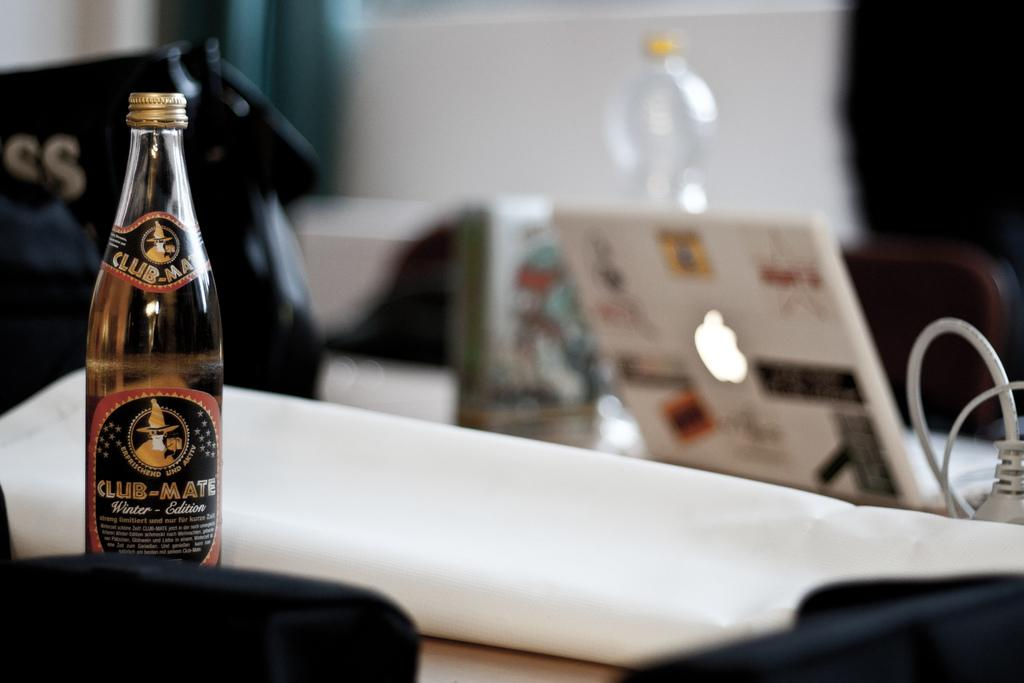What electronic device is visible in the image? There is a laptop in the image. What type of visual representation can be seen in the image? There is a chart in the image. What type of container is present in the image? There is a bottle in the image, specifically a water bottle. What is the bottle filled with? The bottle is filled with some liquid. What is written on the bottle? The bottle has "club mate" written on it. What type of accessory is present in the image? There is a bag in the image. What example of a dime can be seen in the image? There is no dime present in the image. What type of border is depicted in the image? The image does not show any borders; it features a laptop, chart, bottle, water bottle, liquid, "club mate" writing, and a bag. 